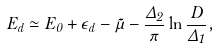Convert formula to latex. <formula><loc_0><loc_0><loc_500><loc_500>E _ { d } \simeq E _ { 0 } + \epsilon _ { d } - \tilde { \mu } - \frac { \Delta _ { 2 } } { \pi } \ln \frac { D } { \Delta _ { 1 } } ,</formula> 